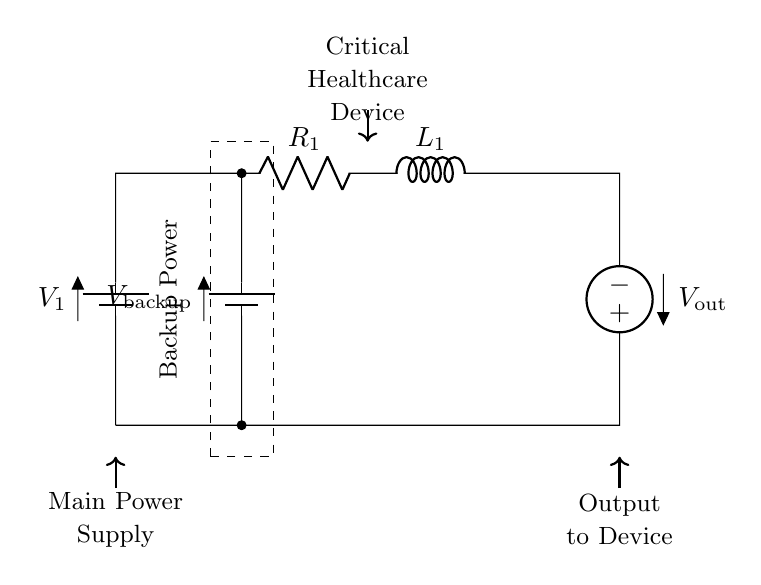What is the main power supply voltage? The main power supply voltage is represented by the symbol V1 in the diagram, but the actual voltage value is not specified here. Typically, it could be 5V or 12V depending on the application.
Answer: V1 What is the purpose of the backup battery? The backup battery, labeled V_backup, serves to provide power when the main power supply is not available, ensuring that critical healthcare devices remain operational during outages.
Answer: Power continuity How many components are in the series circuit? The circuit includes four primary components: one battery (V1), one resistor (R1), one inductor (L1), and one backup battery (V_backup). This adds up to a total of four main components.
Answer: Four What connects the backup battery to the circuit? The backup battery is connected to the circuit through a series of short connections, specifically directly to the upper path of the circuit that connects the battery to the healthcare device.
Answer: Short connections What type of circuit is shown? The circuit is specifically a series circuit where all components are connected in a single loop, providing one path for current flow from the main power supply through the backup to the load.
Answer: Series circuit Which direction does the output voltage flow? The output voltage flows downward from the output component (V_out) at the right side of the circuit towards the bottom, indicating the intended direction of current flow to the connected healthcare device.
Answer: Downward 